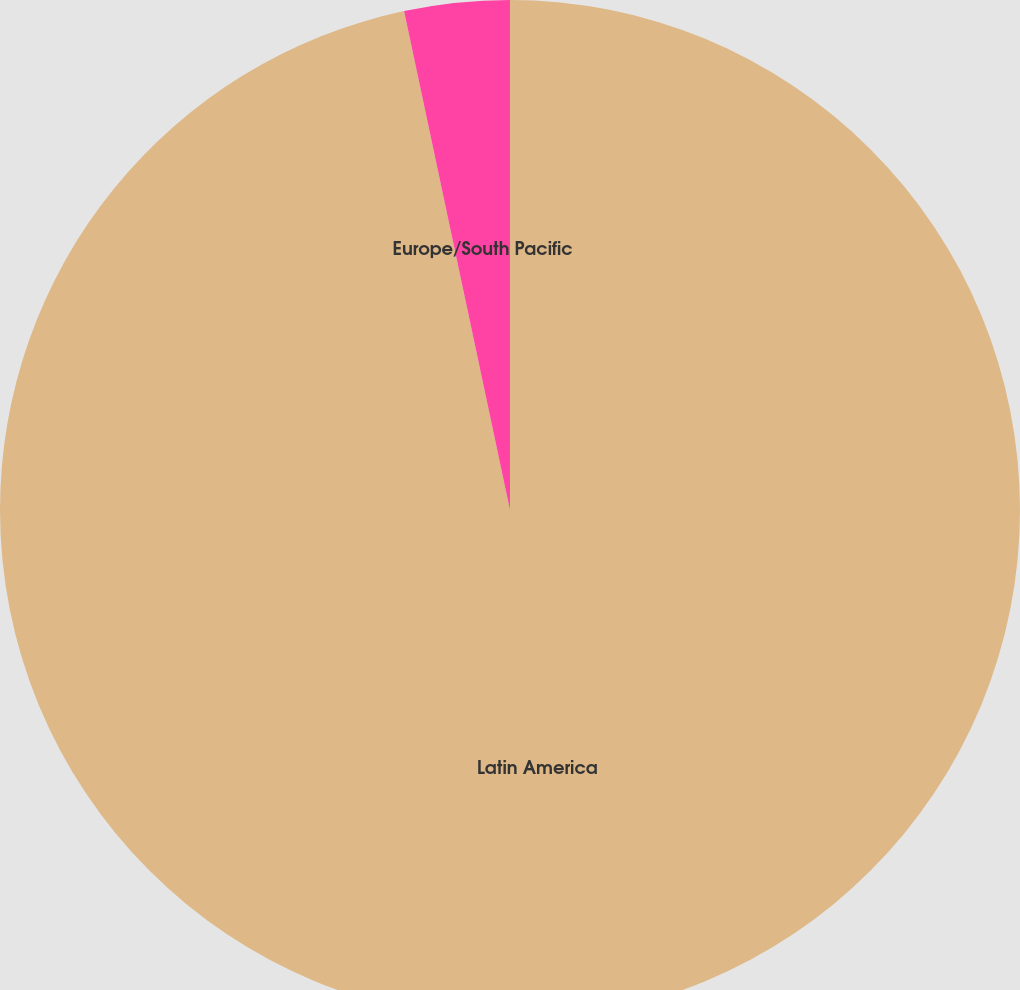Convert chart to OTSL. <chart><loc_0><loc_0><loc_500><loc_500><pie_chart><fcel>Latin America<fcel>Europe/South Pacific<nl><fcel>96.67%<fcel>3.33%<nl></chart> 